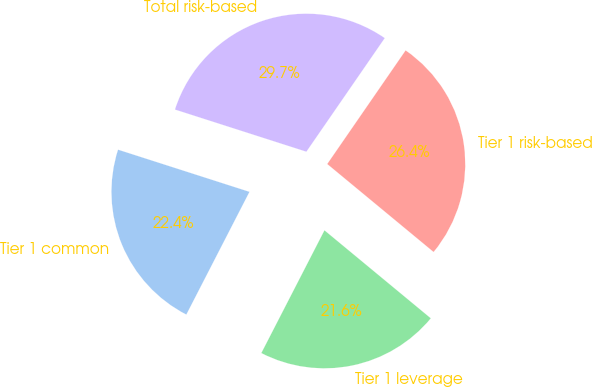Convert chart to OTSL. <chart><loc_0><loc_0><loc_500><loc_500><pie_chart><fcel>Tier 1 common<fcel>Tier 1 leverage<fcel>Tier 1 risk-based<fcel>Total risk-based<nl><fcel>22.38%<fcel>21.56%<fcel>26.39%<fcel>29.67%<nl></chart> 